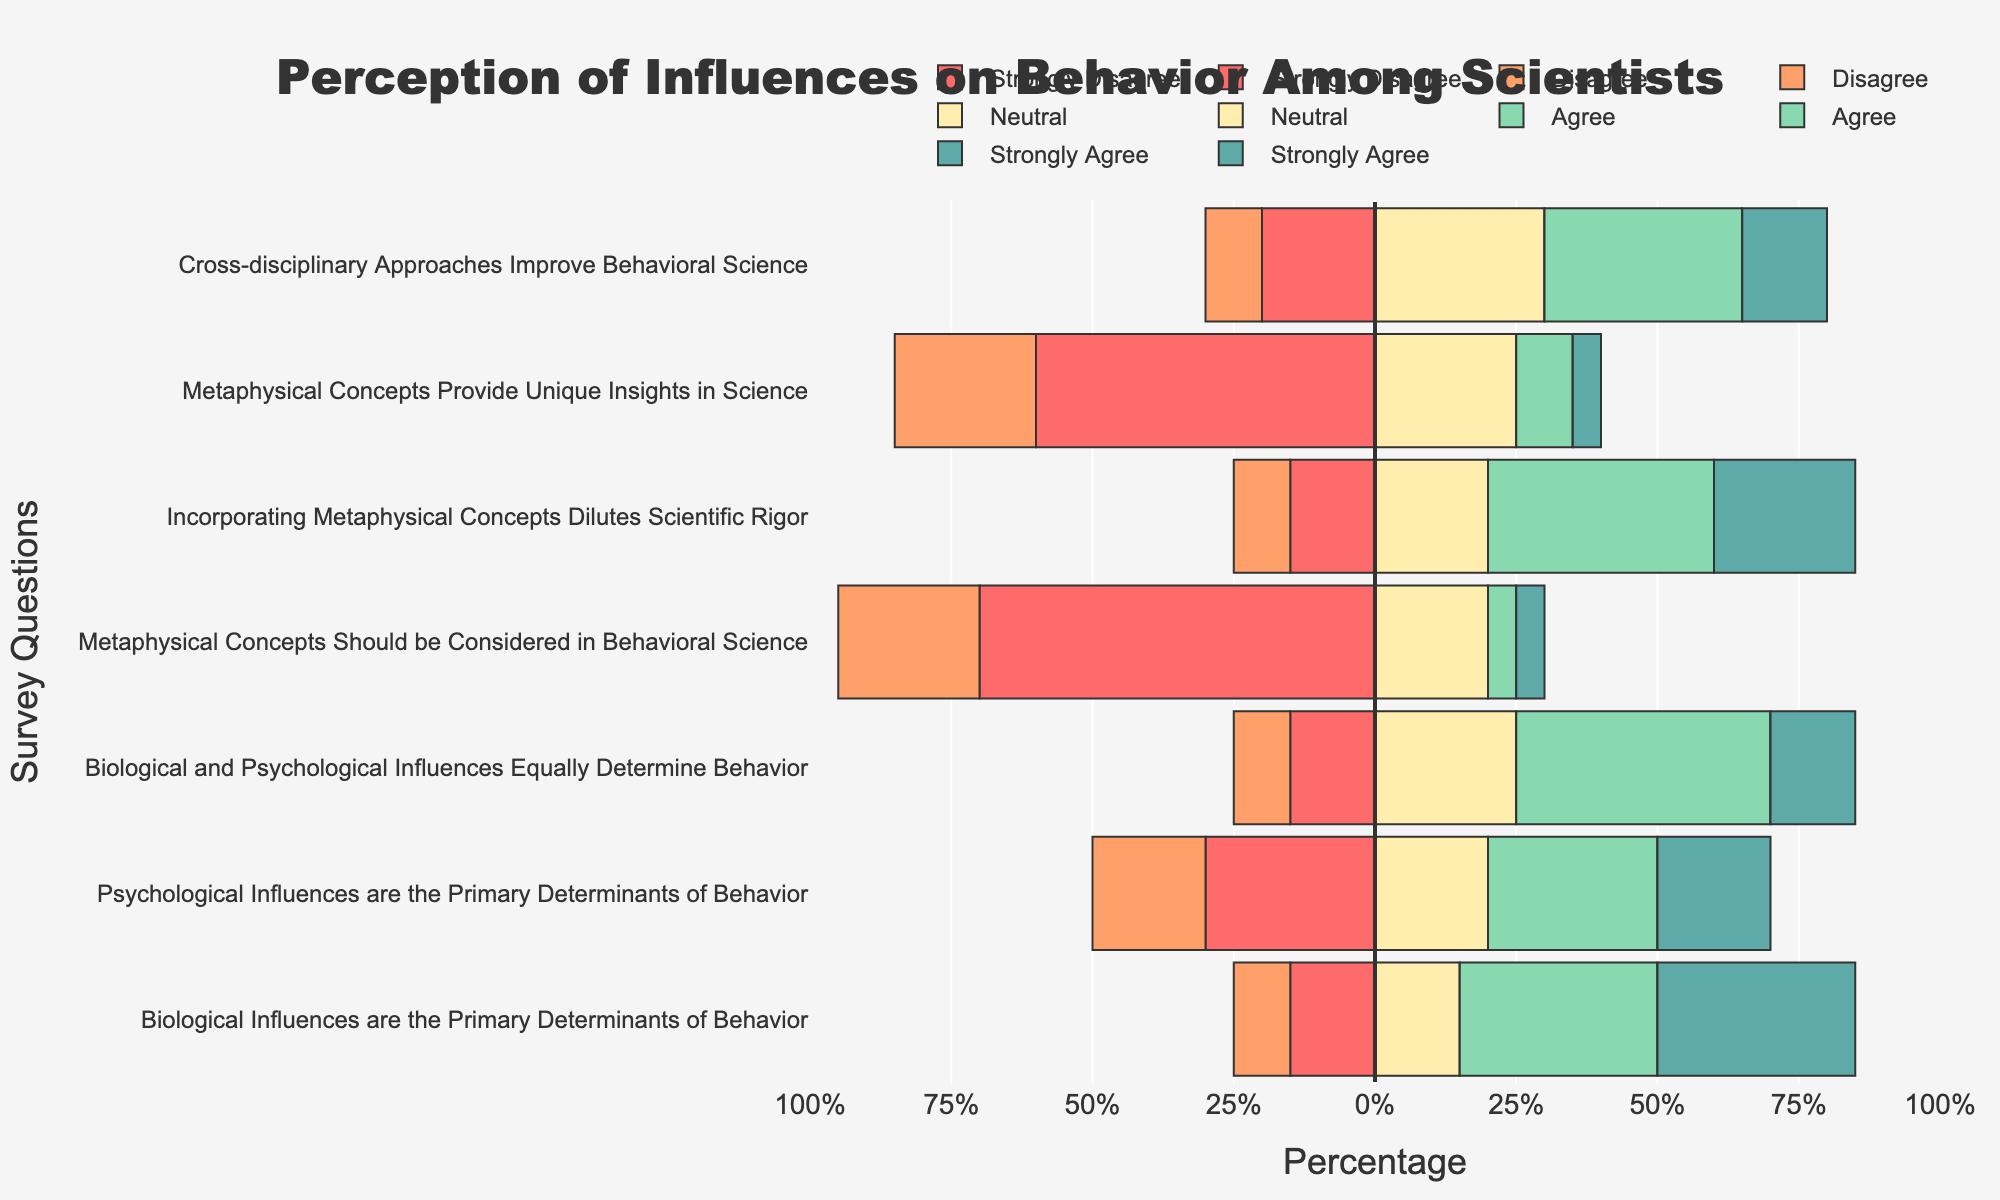What percentage of scientists Strongly Disagree that metaphysical concepts provide unique insights in science? The bar for "Metaphysical Concepts Provide Unique Insights in Science" corresponding to "Strongly Disagree" extends to about 35% on the negative side.
Answer: 35% Which survey question had the highest percentage of "Agree"? The "Agree" section which extends the most on the positive side is for the question "Biological Influences are the Primary Determinants of Behavior."
Answer: Biological Influences are the Primary Determinants of Behavior Comparing "Metaphysical Concepts Should be Considered in Behavioral Science" and "Incorporating Metaphysical Concepts Dilutes Scientific Rigor," which had more "Strongly Disagree" responses? The bar for "Strongly Disagree" is longer for "Metaphysical Concepts Should be Considered in Behavioral Science," which is about 45%, compared to 5% for "Incorporating Metaphysical Concepts Dilutes Scientific Rigor."
Answer: Metaphysical Concepts Should be Considered in Behavioral Science What is the combined percentage of responses that either Agree or Strongly Agree that cross-disciplinary approaches improve behavioral science? Adding the "Agree" (35%) and "Strongly Agree" (15%) sections, the sum for "Cross-disciplinary Approaches Improve Behavioral Science" is 50%.
Answer: 50% Which statement had the highest disagreement (Strongly Disagree + Disagree)? For each question, sum the percentages of "Strongly Disagree" and "Disagree." The highest is "Metaphysical Concepts Should be Considered in Behavioral Science" with 45% (Strongly Disagree) + 25% (Disagree) = 70%.
Answer: Metaphysical Concepts Should be Considered in Behavioral Science Between "Psychological Influences are the Primary Determinants of Behavior” and "Biological and Psychological Influences Equally Determine Behavior," which had a higher percentage of Neutral responses? The Neutral section bar for "Psychological Influences are the Primary Determinants of Behavior" is about 20%, whereas for "Biological and Psychological Influences Equally Determine Behavior," the bar is 25%.
Answer: Biological and Psychological Influences Equally Determine Behavior How do the percentages of "Strongly Agree" responses for "Biological Influences are the Primary Determinants of Behavior" and "Psychological Influences are the Primary Determinants of Behavior" compare? The "Strongly Agree" bar extends to 35% for "Biological Influences are the Primary Determinants of Behavior" and 20% for "Psychological Influences are the Primary Determinants of Behavior."
Answer: Biological Influences are the Primary Determinants of Behavior is higher Is there any question where the combined percentage of "Strongly Disagree" and "Disagree" is equal to the combined percentage of "Agree" and "Strongly Agree"? For "Metaphysical Concepts Provide Unique Insights in Science,” summing "Strongly Disagree" (35%) and "Disagree" (25%) gives 60%, and "Agree" (10%) and "Strongly Agree" (5%) also sum to 15%. Not equal for any.
Answer: No, none What percentage of scientists are Neutral about "Incorporating Metaphysical Concepts Dilutes Scientific Rigor"? The Neutral bar for "Incorporating Metaphysical Concepts Dilutes Scientific Rigor" extends to about 20%.
Answer: 20% 